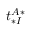<formula> <loc_0><loc_0><loc_500><loc_500>t _ { * I } ^ { A * }</formula> 